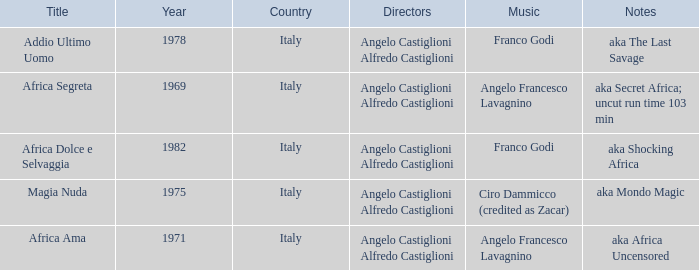How many years have a Title of Magia Nuda? 1.0. 